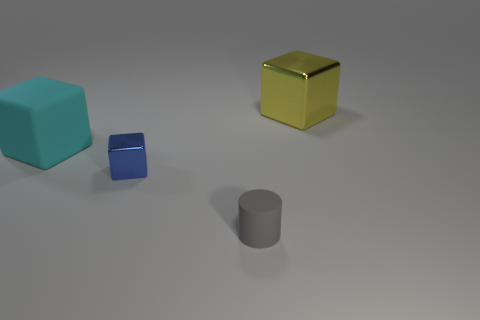Subtract all small blocks. How many blocks are left? 2 Subtract all cubes. How many objects are left? 1 Add 1 large blocks. How many objects exist? 5 Subtract 1 cubes. How many cubes are left? 2 Subtract all yellow cubes. How many cubes are left? 2 Subtract 0 brown cylinders. How many objects are left? 4 Subtract all purple cylinders. Subtract all cyan blocks. How many cylinders are left? 1 Subtract all gray spheres. How many green cylinders are left? 0 Subtract all large blocks. Subtract all matte cylinders. How many objects are left? 1 Add 1 blue things. How many blue things are left? 2 